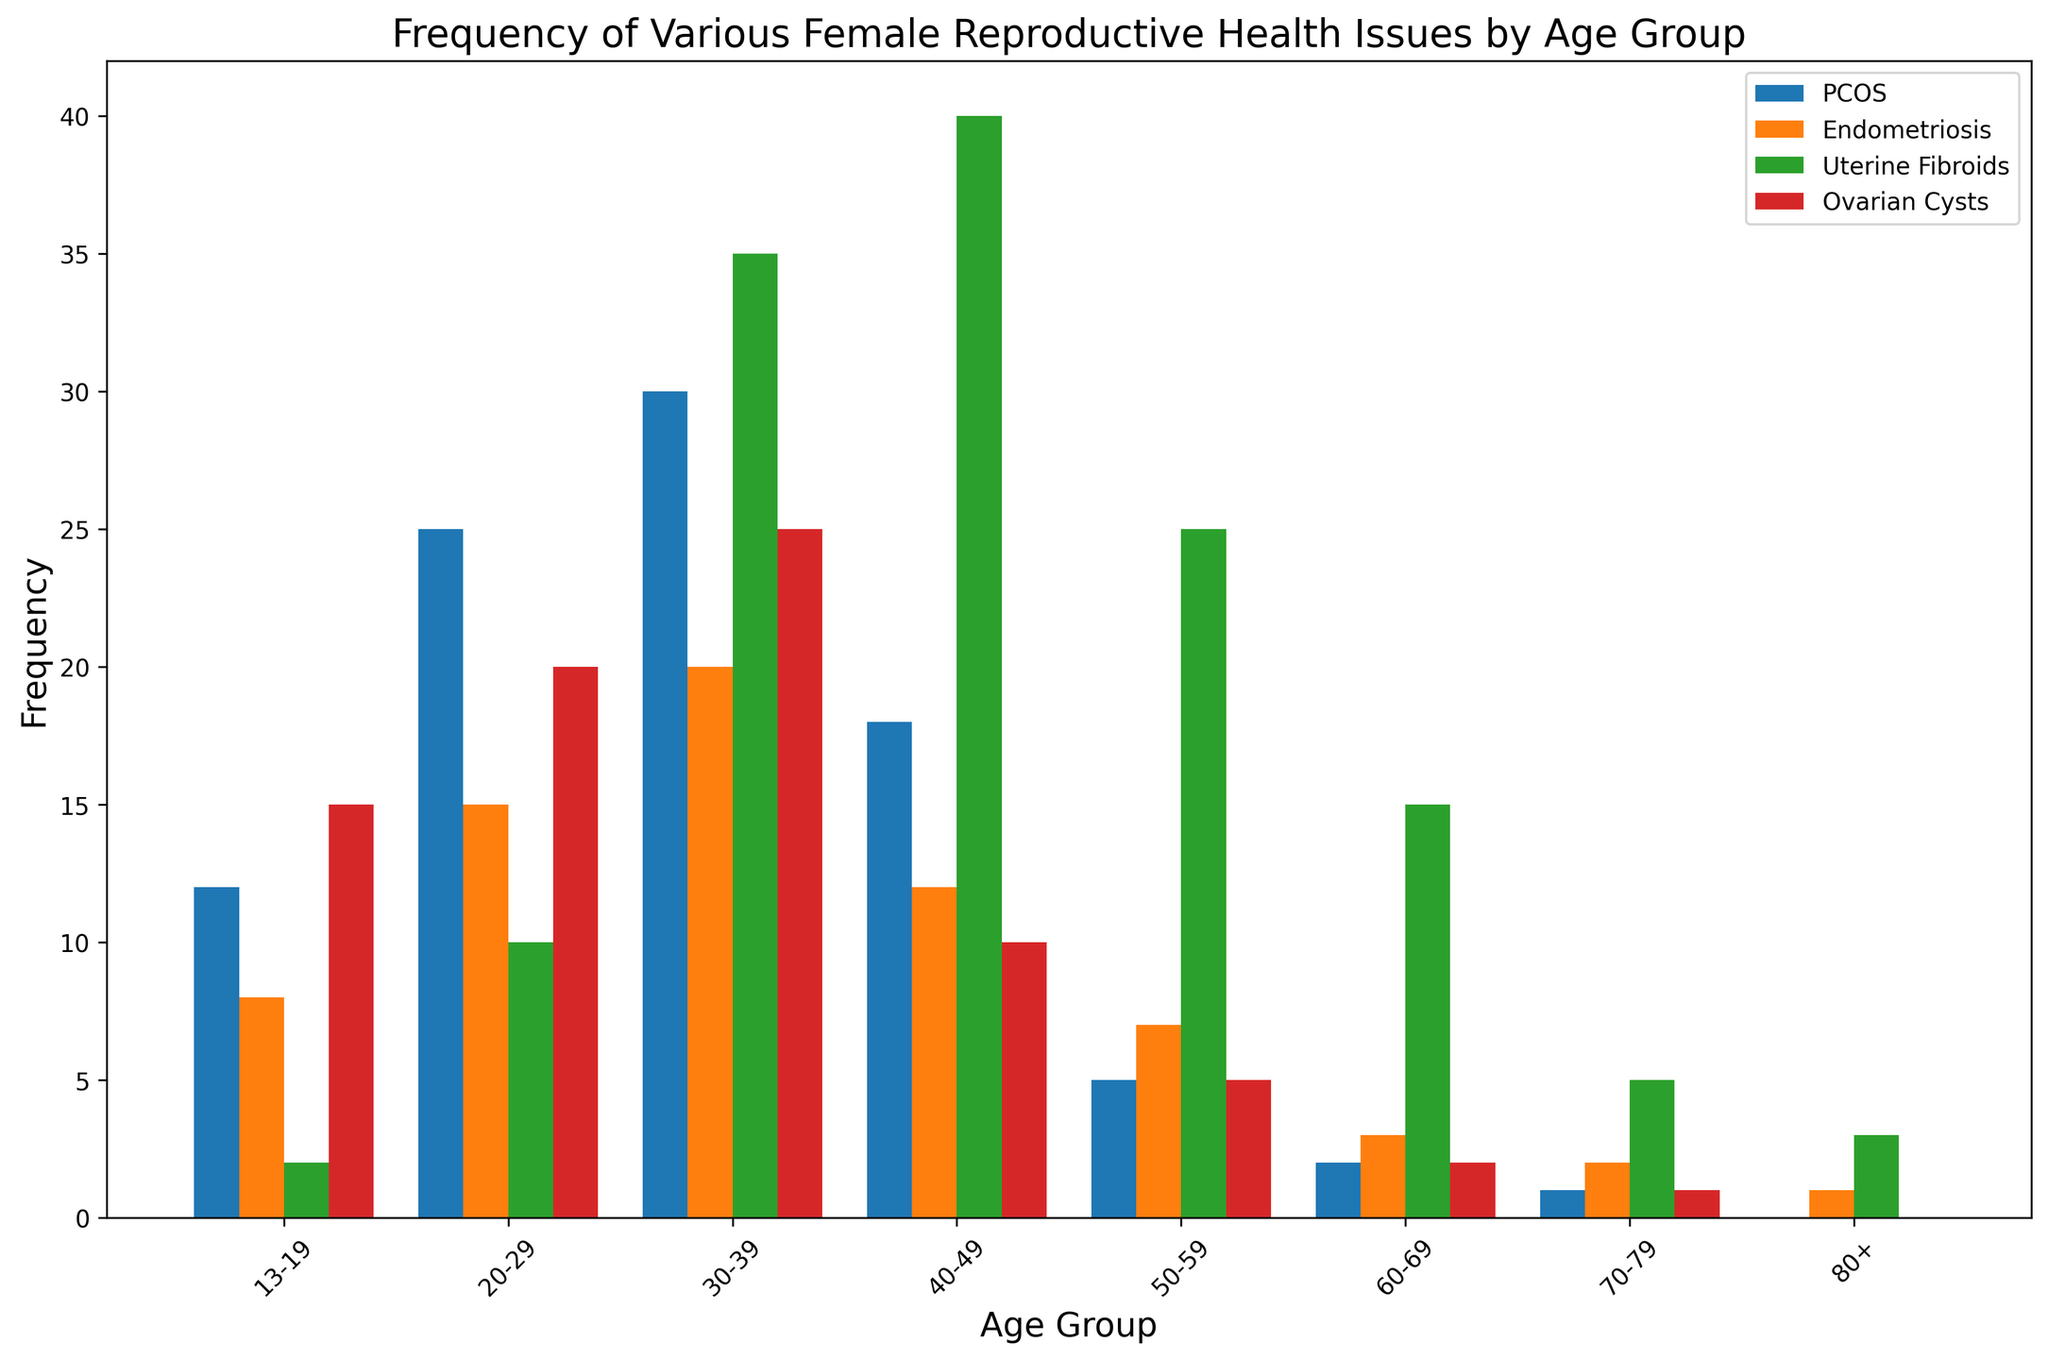What age group has the highest frequency of Uterine Fibroids? Look at the histogram bars for Uterine Fibroids (each age group) and identify the tallest bar. The tallest bar for Uterine Fibroids is in the 40-49 age group.
Answer: 40-49 In which age group is PCOS more frequent than Ovarian Cysts, and by how much? Compare the PCOS and Ovarian Cysts bars in each age group. The age group where the PCOS bar is taller than the Ovarian Cysts bar is 40-49. The frequency of PCOS is 18 and Ovarian Cysts is 10, giving a difference of 8.
Answer: 40-49, by 8 Which historical discovery corresponds to the age group with the highest frequency of Endometriosis cases? Identify the age group with the highest Endometriosis frequency by comparing the bars and check the corresponding historical discovery stated for that age group. The age group 30-39 has the highest frequency of Endometriosis (20 cases) and corresponds to Luigi Bandl’s tubo-ovarian abscess detail in 1876.
Answer: Luigi Bandl’s tubo-ovarian abscess detail in 1876 What is the total frequency of all health issues combined for the age group 20-29? Sum the frequencies of Endometriosis, PCOS, Uterine Fibroids, and Ovarian Cysts for the age group 20-29. The frequencies are 25 (PCOS) + 15 (Endometriosis) + 10 (Uterine Fibroids) + 20 (Ovarian Cysts) = 70.
Answer: 70 Which condition shows a decreasing trend in frequency as age increases? Observe the histogram bars for each condition and identify the one with consistently decreasing bars as age increases. Ovarian Cysts frequency decreases as age increases: 15, 20, 25, 10, 5, 2, 1, 0.
Answer: Ovarian Cysts How do the frequencies of Uterine Fibroids and Endometriosis in the 30-39 age group compare? Check the height of the histogram bars for Uterine Fibroids (35) and Endometriosis (20) in the 30-39 age group. Uterine Fibroids (35) is higher than Endometriosis (20).
Answer: Uterine Fibroids are higher What is the average frequency of Ovarian Cysts for all age groups? Sum the frequencies of Ovarian Cysts for all age groups and divide by the number of age groups. The frequencies are 15, 20, 25, 10, 5, 2, 1, 0, which sum to 78. There are 8 age groups, so the average is 78 / 8 = 9.75.
Answer: 9.75 Which historical discovery is associated with the age group with the lowest overall frequency of reproductive health issues? First, find the age group with the lowest total frequency (which is the sum of PCOS, Endometriosis, Uterine Fibroids, and Ovarian Cysts), then match it with the historical discovery. The age group 80+ has the lowest total frequency (4) and corresponds to James Marion Sims' work in the 19th century.
Answer: James Marion Sims' work in the 19th century 